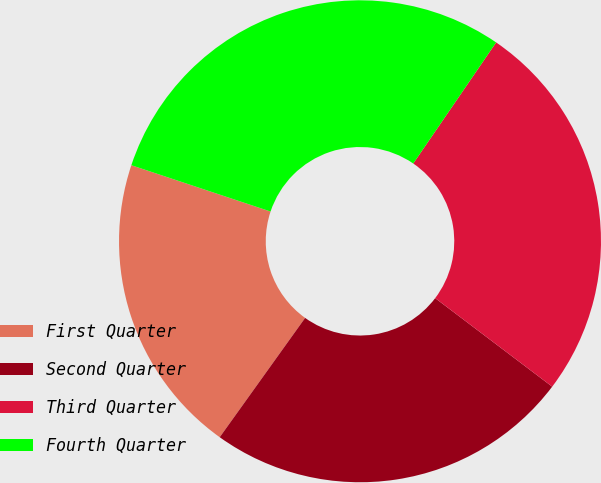Convert chart to OTSL. <chart><loc_0><loc_0><loc_500><loc_500><pie_chart><fcel>First Quarter<fcel>Second Quarter<fcel>Third Quarter<fcel>Fourth Quarter<nl><fcel>20.22%<fcel>24.58%<fcel>25.75%<fcel>29.44%<nl></chart> 